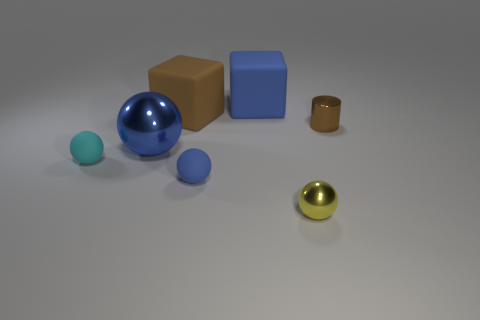I'm curious about the colors in the picture. Could you describe the different colors you see? Certainly! In this image, there's a blue sphere, a smaller teal sphere, a large brown block, a smaller blue block, and two metal balls—one appears to be standard steel, and the other has a golden hue. The background is a neutral gray. Which object seems out of place in this collection? The golden metal ball might seem out of place as its color and sheen differ significantly from the other objects, suggesting it is of distinct material or importance. 